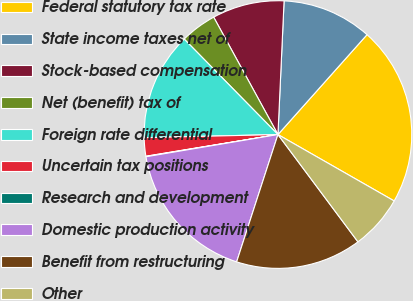<chart> <loc_0><loc_0><loc_500><loc_500><pie_chart><fcel>Federal statutory tax rate<fcel>State income taxes net of<fcel>Stock-based compensation<fcel>Net (benefit) tax of<fcel>Foreign rate differential<fcel>Uncertain tax positions<fcel>Research and development<fcel>Domestic production activity<fcel>Benefit from restructuring<fcel>Other<nl><fcel>21.67%<fcel>10.86%<fcel>8.7%<fcel>4.38%<fcel>13.02%<fcel>2.22%<fcel>0.06%<fcel>17.35%<fcel>15.19%<fcel>6.54%<nl></chart> 